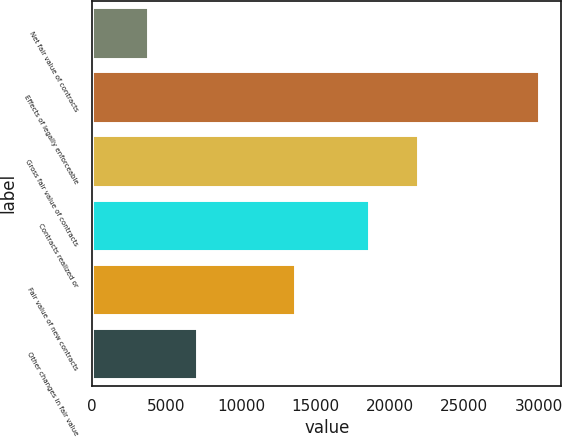Convert chart to OTSL. <chart><loc_0><loc_0><loc_500><loc_500><bar_chart><fcel>Net fair value of contracts<fcel>Effects of legally enforceable<fcel>Gross fair value of contracts<fcel>Contracts realized or<fcel>Fair value of new contracts<fcel>Other changes in fair value<nl><fcel>3758<fcel>30021<fcel>21921.9<fcel>18623<fcel>13654.7<fcel>7056.9<nl></chart> 